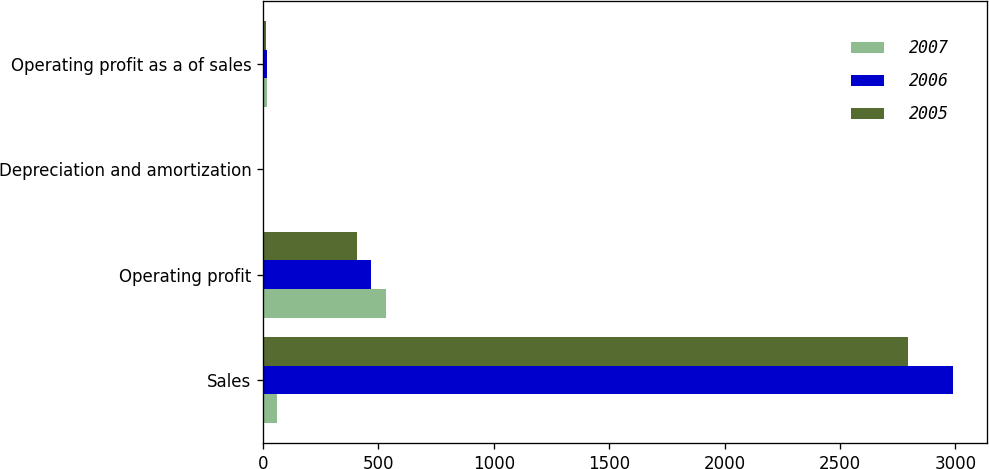<chart> <loc_0><loc_0><loc_500><loc_500><stacked_bar_chart><ecel><fcel>Sales<fcel>Operating profit<fcel>Depreciation and amortization<fcel>Operating profit as a of sales<nl><fcel>2007<fcel>60.75<fcel>532.5<fcel>2<fcel>16.9<nl><fcel>2006<fcel>2988.8<fcel>467.7<fcel>2<fcel>15.7<nl><fcel>2005<fcel>2794.9<fcel>409.3<fcel>2.2<fcel>14.6<nl></chart> 